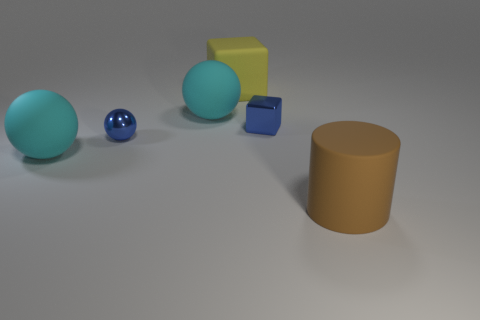Add 4 yellow matte cubes. How many objects exist? 10 Subtract all cylinders. How many objects are left? 5 Add 5 large blocks. How many large blocks are left? 6 Add 4 large purple matte balls. How many large purple matte balls exist? 4 Subtract 0 purple blocks. How many objects are left? 6 Subtract all gray blocks. Subtract all cylinders. How many objects are left? 5 